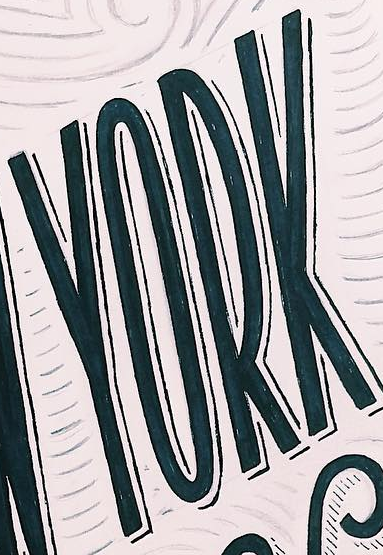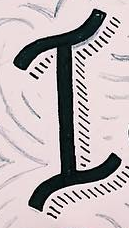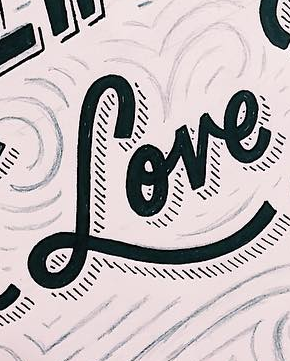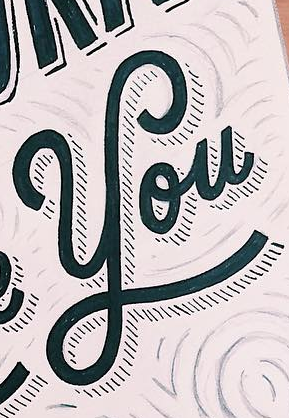Read the text content from these images in order, separated by a semicolon. YORK; I; Love; You 